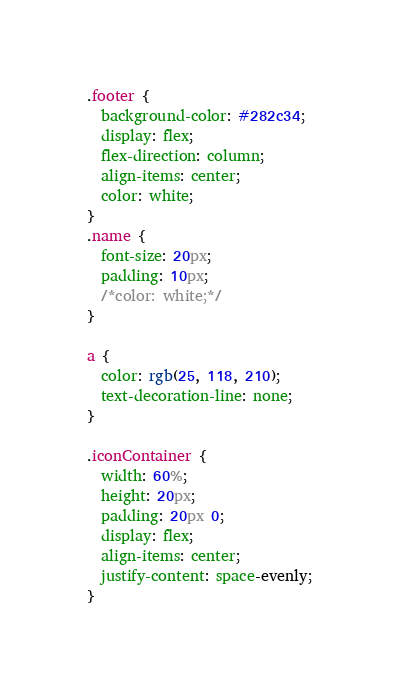Convert code to text. <code><loc_0><loc_0><loc_500><loc_500><_CSS_>.footer {
  background-color: #282c34;
  display: flex;
  flex-direction: column;
  align-items: center;
  color: white;
}
.name {
  font-size: 20px;
  padding: 10px;
  /*color: white;*/
}

a {
  color: rgb(25, 118, 210);
  text-decoration-line: none;
}

.iconContainer {
  width: 60%;
  height: 20px;
  padding: 20px 0;
  display: flex;
  align-items: center;
  justify-content: space-evenly;
}
</code> 